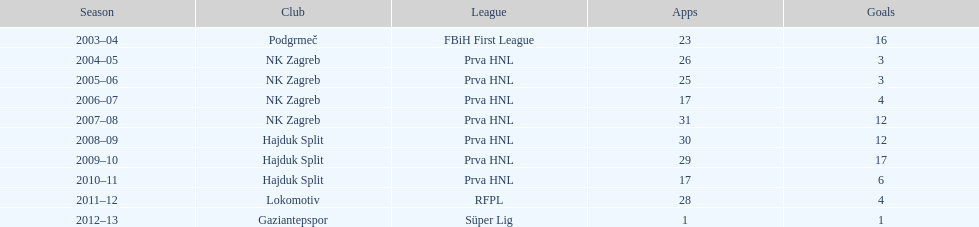What is the maximum number of goals netted by senijad ibricić in a single season? 35. 